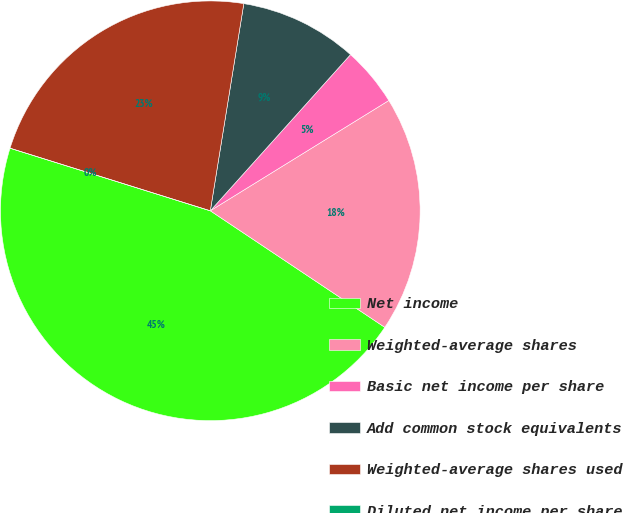Convert chart. <chart><loc_0><loc_0><loc_500><loc_500><pie_chart><fcel>Net income<fcel>Weighted-average shares<fcel>Basic net income per share<fcel>Add common stock equivalents<fcel>Weighted-average shares used<fcel>Diluted net income per share<nl><fcel>45.45%<fcel>18.18%<fcel>4.55%<fcel>9.09%<fcel>22.73%<fcel>0.0%<nl></chart> 